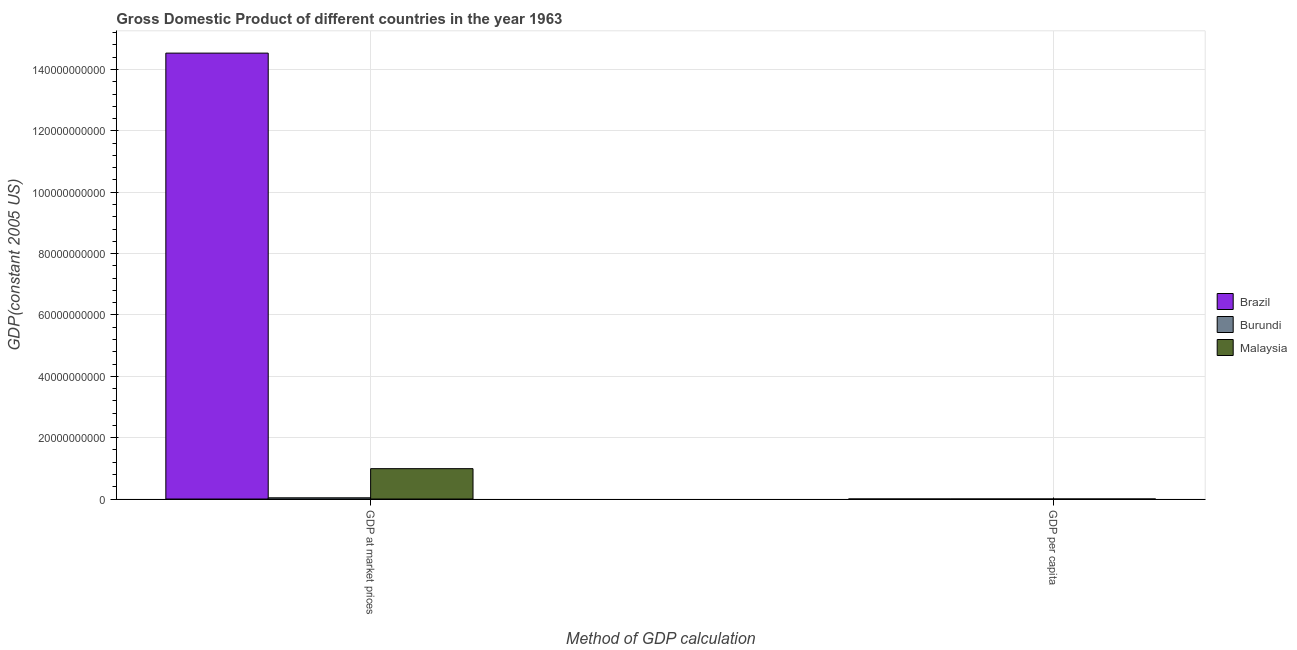How many groups of bars are there?
Offer a terse response. 2. Are the number of bars on each tick of the X-axis equal?
Give a very brief answer. Yes. What is the label of the 2nd group of bars from the left?
Provide a short and direct response. GDP per capita. What is the gdp per capita in Brazil?
Keep it short and to the point. 1831.02. Across all countries, what is the maximum gdp at market prices?
Your answer should be very brief. 1.45e+11. Across all countries, what is the minimum gdp per capita?
Offer a terse response. 136. In which country was the gdp per capita minimum?
Ensure brevity in your answer.  Burundi. What is the total gdp per capita in the graph?
Keep it short and to the point. 3066.57. What is the difference between the gdp per capita in Brazil and that in Malaysia?
Offer a terse response. 731.48. What is the difference between the gdp per capita in Brazil and the gdp at market prices in Burundi?
Keep it short and to the point. -4.01e+08. What is the average gdp per capita per country?
Offer a very short reply. 1022.19. What is the difference between the gdp at market prices and gdp per capita in Burundi?
Provide a short and direct response. 4.01e+08. What is the ratio of the gdp at market prices in Brazil to that in Malaysia?
Keep it short and to the point. 14.69. Is the gdp at market prices in Malaysia less than that in Brazil?
Your response must be concise. Yes. In how many countries, is the gdp at market prices greater than the average gdp at market prices taken over all countries?
Provide a succinct answer. 1. What does the 3rd bar from the left in GDP at market prices represents?
Offer a very short reply. Malaysia. What does the 2nd bar from the right in GDP per capita represents?
Your answer should be compact. Burundi. How many bars are there?
Your answer should be very brief. 6. Does the graph contain grids?
Provide a short and direct response. Yes. How many legend labels are there?
Make the answer very short. 3. How are the legend labels stacked?
Give a very brief answer. Vertical. What is the title of the graph?
Ensure brevity in your answer.  Gross Domestic Product of different countries in the year 1963. Does "Dominica" appear as one of the legend labels in the graph?
Give a very brief answer. No. What is the label or title of the X-axis?
Make the answer very short. Method of GDP calculation. What is the label or title of the Y-axis?
Ensure brevity in your answer.  GDP(constant 2005 US). What is the GDP(constant 2005 US) in Brazil in GDP at market prices?
Offer a terse response. 1.45e+11. What is the GDP(constant 2005 US) in Burundi in GDP at market prices?
Give a very brief answer. 4.01e+08. What is the GDP(constant 2005 US) in Malaysia in GDP at market prices?
Give a very brief answer. 9.90e+09. What is the GDP(constant 2005 US) in Brazil in GDP per capita?
Your answer should be very brief. 1831.02. What is the GDP(constant 2005 US) of Burundi in GDP per capita?
Offer a very short reply. 136. What is the GDP(constant 2005 US) in Malaysia in GDP per capita?
Keep it short and to the point. 1099.55. Across all Method of GDP calculation, what is the maximum GDP(constant 2005 US) in Brazil?
Your answer should be very brief. 1.45e+11. Across all Method of GDP calculation, what is the maximum GDP(constant 2005 US) of Burundi?
Keep it short and to the point. 4.01e+08. Across all Method of GDP calculation, what is the maximum GDP(constant 2005 US) of Malaysia?
Ensure brevity in your answer.  9.90e+09. Across all Method of GDP calculation, what is the minimum GDP(constant 2005 US) in Brazil?
Provide a succinct answer. 1831.02. Across all Method of GDP calculation, what is the minimum GDP(constant 2005 US) of Burundi?
Provide a short and direct response. 136. Across all Method of GDP calculation, what is the minimum GDP(constant 2005 US) in Malaysia?
Offer a terse response. 1099.55. What is the total GDP(constant 2005 US) of Brazil in the graph?
Your response must be concise. 1.45e+11. What is the total GDP(constant 2005 US) in Burundi in the graph?
Provide a succinct answer. 4.01e+08. What is the total GDP(constant 2005 US) of Malaysia in the graph?
Your response must be concise. 9.90e+09. What is the difference between the GDP(constant 2005 US) in Brazil in GDP at market prices and that in GDP per capita?
Your response must be concise. 1.45e+11. What is the difference between the GDP(constant 2005 US) in Burundi in GDP at market prices and that in GDP per capita?
Offer a very short reply. 4.01e+08. What is the difference between the GDP(constant 2005 US) of Malaysia in GDP at market prices and that in GDP per capita?
Your response must be concise. 9.90e+09. What is the difference between the GDP(constant 2005 US) in Brazil in GDP at market prices and the GDP(constant 2005 US) in Burundi in GDP per capita?
Offer a very short reply. 1.45e+11. What is the difference between the GDP(constant 2005 US) in Brazil in GDP at market prices and the GDP(constant 2005 US) in Malaysia in GDP per capita?
Your answer should be compact. 1.45e+11. What is the difference between the GDP(constant 2005 US) of Burundi in GDP at market prices and the GDP(constant 2005 US) of Malaysia in GDP per capita?
Offer a terse response. 4.01e+08. What is the average GDP(constant 2005 US) of Brazil per Method of GDP calculation?
Your answer should be very brief. 7.27e+1. What is the average GDP(constant 2005 US) of Burundi per Method of GDP calculation?
Ensure brevity in your answer.  2.01e+08. What is the average GDP(constant 2005 US) in Malaysia per Method of GDP calculation?
Provide a short and direct response. 4.95e+09. What is the difference between the GDP(constant 2005 US) in Brazil and GDP(constant 2005 US) in Burundi in GDP at market prices?
Offer a very short reply. 1.45e+11. What is the difference between the GDP(constant 2005 US) of Brazil and GDP(constant 2005 US) of Malaysia in GDP at market prices?
Offer a terse response. 1.35e+11. What is the difference between the GDP(constant 2005 US) of Burundi and GDP(constant 2005 US) of Malaysia in GDP at market prices?
Your response must be concise. -9.49e+09. What is the difference between the GDP(constant 2005 US) in Brazil and GDP(constant 2005 US) in Burundi in GDP per capita?
Your answer should be very brief. 1695.03. What is the difference between the GDP(constant 2005 US) of Brazil and GDP(constant 2005 US) of Malaysia in GDP per capita?
Provide a short and direct response. 731.48. What is the difference between the GDP(constant 2005 US) in Burundi and GDP(constant 2005 US) in Malaysia in GDP per capita?
Provide a short and direct response. -963.55. What is the ratio of the GDP(constant 2005 US) of Brazil in GDP at market prices to that in GDP per capita?
Make the answer very short. 7.94e+07. What is the ratio of the GDP(constant 2005 US) in Burundi in GDP at market prices to that in GDP per capita?
Give a very brief answer. 2.95e+06. What is the ratio of the GDP(constant 2005 US) in Malaysia in GDP at market prices to that in GDP per capita?
Provide a short and direct response. 9.00e+06. What is the difference between the highest and the second highest GDP(constant 2005 US) in Brazil?
Your answer should be very brief. 1.45e+11. What is the difference between the highest and the second highest GDP(constant 2005 US) in Burundi?
Your answer should be compact. 4.01e+08. What is the difference between the highest and the second highest GDP(constant 2005 US) of Malaysia?
Make the answer very short. 9.90e+09. What is the difference between the highest and the lowest GDP(constant 2005 US) in Brazil?
Offer a terse response. 1.45e+11. What is the difference between the highest and the lowest GDP(constant 2005 US) of Burundi?
Your answer should be very brief. 4.01e+08. What is the difference between the highest and the lowest GDP(constant 2005 US) of Malaysia?
Your answer should be very brief. 9.90e+09. 